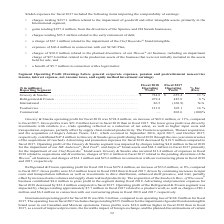According to Conagra Brands's financial document, What was the expense incurred by Grocery & Snacks related to acquisitions and divestitures in the fiscal year 2018? According to the financial document, $11.4 million. The relevant text states: "rdee ® brand asset. Grocery & Snacks also incurred $11.4 million of expenses in fiscal 2018 related to acquisitions and divestitures, charges of $31.4 million in fis..." Also, How much expense was incurred by Refrigerated & Frozen in the company’s restructuring plans in fiscal 2017 and 2018, respectively? The document shows two values: $6.2 million and $0.1 million. From the document: "uct recall, as well as charges of $0.1 million and $6.2 million in connection with our restructuring plans in fiscal 2018 and 2017, respectively. rela..." Also, What was the operating profit in the Foodservice segment in 2017 and 2018, respectively? The document shows two values: 105.1 and 121.8 (in millions). From the document: "Foodservice. . 121.8 105.1 16 % Foodservice. . 121.8 105.1 16 %..." Also, can you calculate: What is the total operating profit of all segments in 2018? Based on the calculation: 724.8+479.4+86.5+121.8 , the result is 1412.5 (in millions). This is based on the information: "Refrigerated & Frozen . 479.4 445.8 8 % International . 86.5 (168.9) N/A Foodservice. . 121.8 105.1 16 % Grocery & Snacks. . $ 724.8 $ 655.4 11 %..." The key data points involved are: 121.8, 479.4, 724.8. Also, can you calculate: What is the ratio of Grocery & Snacks’ operating profit to its expense in restructuring plans for the fiscal year 2018? Based on the calculation: 724.8/14.1 , the result is 51.4. This is based on the information: "Grocery & Snacks. . $ 724.8 $ 655.4 11 % ure of the Wesson ® oil business, and charges of $14.1 million and $23.6 million in connection with our restructuring plans in fiscal 2018 and 2017, respe Groc..." The key data points involved are: 14.1, 724.8. Also, can you calculate: What is the percentage change in total operating profit in 2018 compared to 2017? To answer this question, I need to perform calculations using the financial data. The calculation is: ((724.8+479.4+86.5+121.8)-(655.4+445.8-168.9+105.1+202.6))/(655.4+445.8-168.9+105.1+202.6) , which equals 13.91 (percentage). This is based on the information: "Foodservice. . 121.8 105.1 16 % Commercial. . — 202.6 (100)% Refrigerated & Frozen . 479.4 445.8 8 % Refrigerated & Frozen . 479.4 445.8 8 % Foodservice. . 121.8 105.1 16 % International . 86.5 (168.9..." The key data points involved are: 105.1, 121.8, 168.9. 